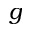Convert formula to latex. <formula><loc_0><loc_0><loc_500><loc_500>g</formula> 